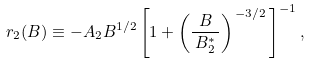<formula> <loc_0><loc_0><loc_500><loc_500>r _ { 2 } ( B ) \equiv - A _ { 2 } B ^ { 1 / 2 } \left [ 1 + \left ( \frac { B } { \, B ^ { * } _ { 2 } \, } \right ) ^ { \, - 3 / 2 } \, \right ] ^ { - 1 } ,</formula> 